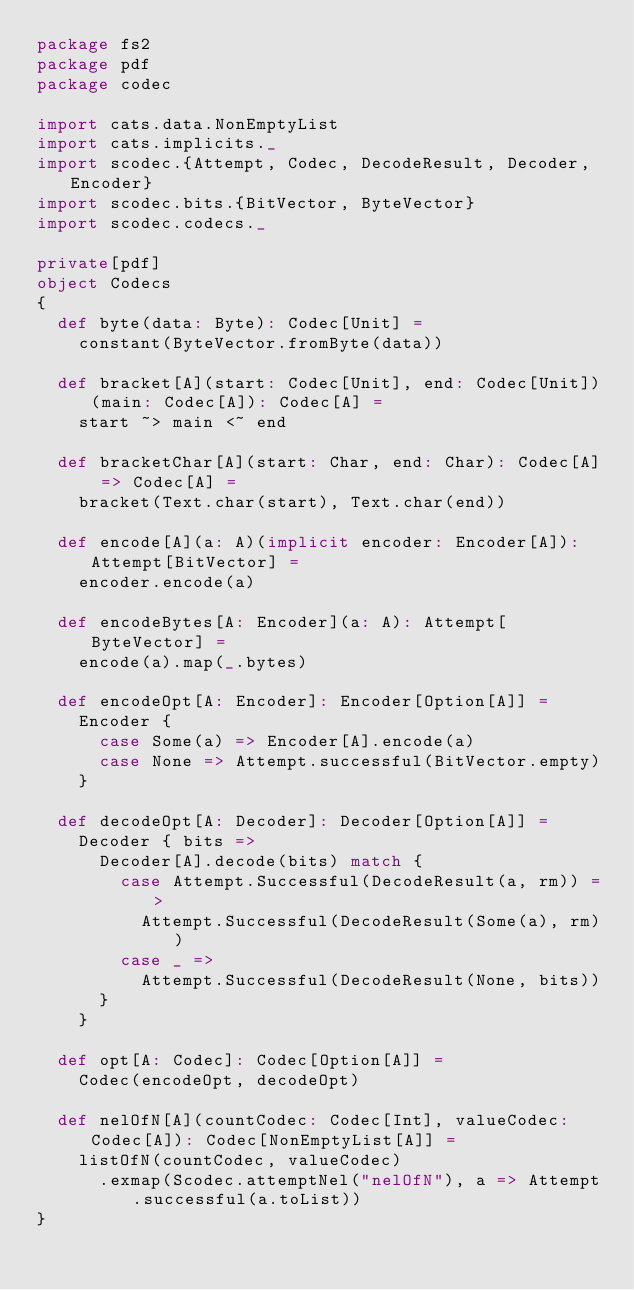<code> <loc_0><loc_0><loc_500><loc_500><_Scala_>package fs2
package pdf
package codec

import cats.data.NonEmptyList
import cats.implicits._
import scodec.{Attempt, Codec, DecodeResult, Decoder, Encoder}
import scodec.bits.{BitVector, ByteVector}
import scodec.codecs._

private[pdf]
object Codecs
{
  def byte(data: Byte): Codec[Unit] =
    constant(ByteVector.fromByte(data))

  def bracket[A](start: Codec[Unit], end: Codec[Unit])(main: Codec[A]): Codec[A] =
    start ~> main <~ end

  def bracketChar[A](start: Char, end: Char): Codec[A] => Codec[A] =
    bracket(Text.char(start), Text.char(end))

  def encode[A](a: A)(implicit encoder: Encoder[A]): Attempt[BitVector] =
    encoder.encode(a)

  def encodeBytes[A: Encoder](a: A): Attempt[ByteVector] =
    encode(a).map(_.bytes)

  def encodeOpt[A: Encoder]: Encoder[Option[A]] =
    Encoder {
      case Some(a) => Encoder[A].encode(a)
      case None => Attempt.successful(BitVector.empty)
    }

  def decodeOpt[A: Decoder]: Decoder[Option[A]] =
    Decoder { bits =>
      Decoder[A].decode(bits) match {
        case Attempt.Successful(DecodeResult(a, rm)) =>
          Attempt.Successful(DecodeResult(Some(a), rm))
        case _ =>
          Attempt.Successful(DecodeResult(None, bits))
      }
    }

  def opt[A: Codec]: Codec[Option[A]] =
    Codec(encodeOpt, decodeOpt)

  def nelOfN[A](countCodec: Codec[Int], valueCodec: Codec[A]): Codec[NonEmptyList[A]] =
    listOfN(countCodec, valueCodec)
      .exmap(Scodec.attemptNel("nelOfN"), a => Attempt.successful(a.toList))
}
</code> 